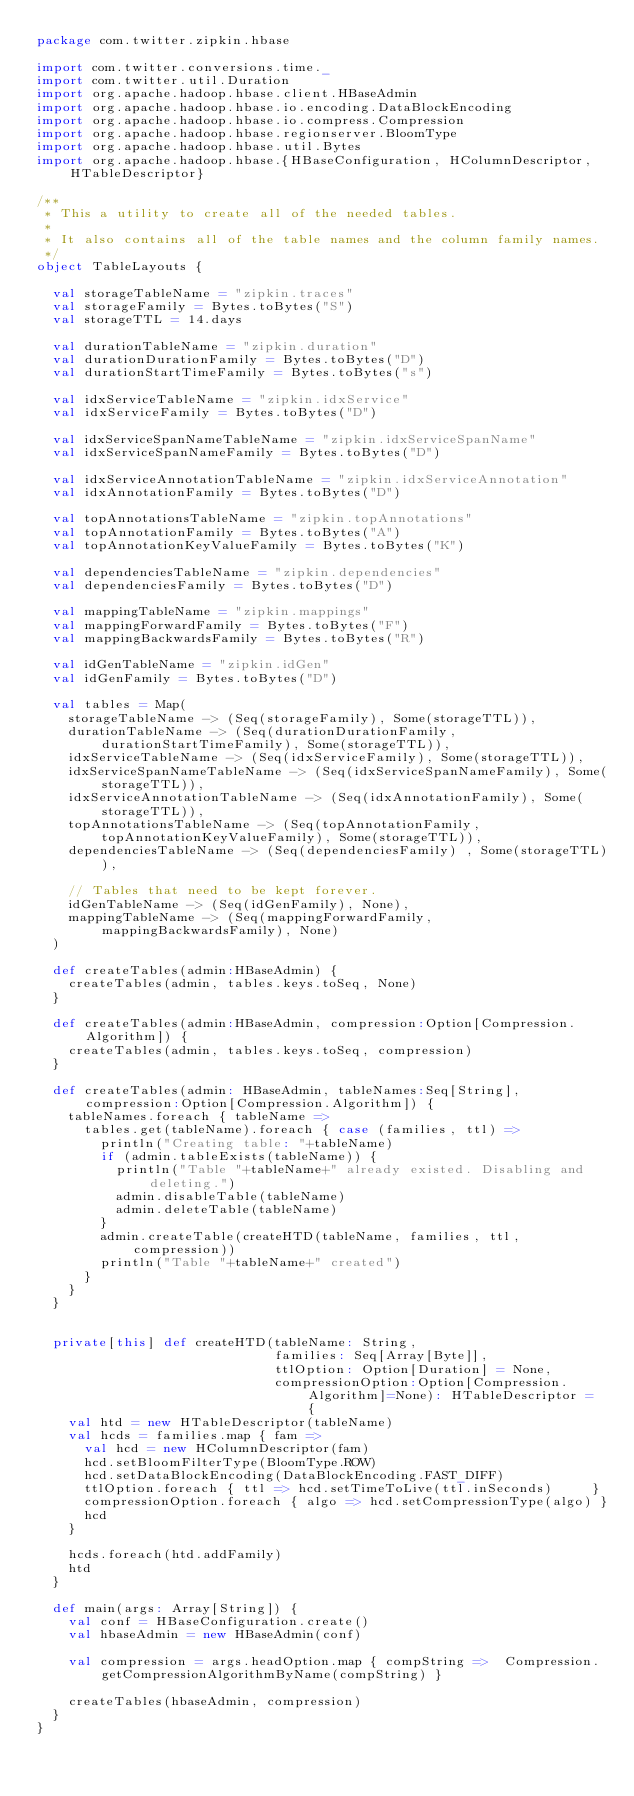<code> <loc_0><loc_0><loc_500><loc_500><_Scala_>package com.twitter.zipkin.hbase

import com.twitter.conversions.time._
import com.twitter.util.Duration
import org.apache.hadoop.hbase.client.HBaseAdmin
import org.apache.hadoop.hbase.io.encoding.DataBlockEncoding
import org.apache.hadoop.hbase.io.compress.Compression
import org.apache.hadoop.hbase.regionserver.BloomType
import org.apache.hadoop.hbase.util.Bytes
import org.apache.hadoop.hbase.{HBaseConfiguration, HColumnDescriptor, HTableDescriptor}

/**
 * This a utility to create all of the needed tables.
 *
 * It also contains all of the table names and the column family names.
 */
object TableLayouts {

  val storageTableName = "zipkin.traces"
  val storageFamily = Bytes.toBytes("S")
  val storageTTL = 14.days

  val durationTableName = "zipkin.duration"
  val durationDurationFamily = Bytes.toBytes("D")
  val durationStartTimeFamily = Bytes.toBytes("s")

  val idxServiceTableName = "zipkin.idxService"
  val idxServiceFamily = Bytes.toBytes("D")

  val idxServiceSpanNameTableName = "zipkin.idxServiceSpanName"
  val idxServiceSpanNameFamily = Bytes.toBytes("D")

  val idxServiceAnnotationTableName = "zipkin.idxServiceAnnotation"
  val idxAnnotationFamily = Bytes.toBytes("D")

  val topAnnotationsTableName = "zipkin.topAnnotations"
  val topAnnotationFamily = Bytes.toBytes("A")
  val topAnnotationKeyValueFamily = Bytes.toBytes("K")

  val dependenciesTableName = "zipkin.dependencies"
  val dependenciesFamily = Bytes.toBytes("D")

  val mappingTableName = "zipkin.mappings"
  val mappingForwardFamily = Bytes.toBytes("F")
  val mappingBackwardsFamily = Bytes.toBytes("R")

  val idGenTableName = "zipkin.idGen"
  val idGenFamily = Bytes.toBytes("D")

  val tables = Map(
    storageTableName -> (Seq(storageFamily), Some(storageTTL)),
    durationTableName -> (Seq(durationDurationFamily, durationStartTimeFamily), Some(storageTTL)),
    idxServiceTableName -> (Seq(idxServiceFamily), Some(storageTTL)),
    idxServiceSpanNameTableName -> (Seq(idxServiceSpanNameFamily), Some(storageTTL)),
    idxServiceAnnotationTableName -> (Seq(idxAnnotationFamily), Some(storageTTL)),
    topAnnotationsTableName -> (Seq(topAnnotationFamily, topAnnotationKeyValueFamily), Some(storageTTL)),
    dependenciesTableName -> (Seq(dependenciesFamily) , Some(storageTTL)),

    // Tables that need to be kept forever.
    idGenTableName -> (Seq(idGenFamily), None),
    mappingTableName -> (Seq(mappingForwardFamily, mappingBackwardsFamily), None)
  )

  def createTables(admin:HBaseAdmin) {
    createTables(admin, tables.keys.toSeq, None)
  }

  def createTables(admin:HBaseAdmin, compression:Option[Compression.Algorithm]) {
    createTables(admin, tables.keys.toSeq, compression)
  }

  def createTables(admin: HBaseAdmin, tableNames:Seq[String], compression:Option[Compression.Algorithm]) {
    tableNames.foreach { tableName =>
      tables.get(tableName).foreach { case (families, ttl) =>
        println("Creating table: "+tableName)
        if (admin.tableExists(tableName)) {
          println("Table "+tableName+" already existed. Disabling and deleting.")
          admin.disableTable(tableName)
          admin.deleteTable(tableName)
        }
        admin.createTable(createHTD(tableName, families, ttl, compression))
        println("Table "+tableName+" created")
      }
    }
  }


  private[this] def createHTD(tableName: String,
                              families: Seq[Array[Byte]],
                              ttlOption: Option[Duration] = None,
                              compressionOption:Option[Compression.Algorithm]=None): HTableDescriptor = {
    val htd = new HTableDescriptor(tableName)
    val hcds = families.map { fam =>
      val hcd = new HColumnDescriptor(fam)
      hcd.setBloomFilterType(BloomType.ROW)
      hcd.setDataBlockEncoding(DataBlockEncoding.FAST_DIFF)
      ttlOption.foreach { ttl => hcd.setTimeToLive(ttl.inSeconds)     }
      compressionOption.foreach { algo => hcd.setCompressionType(algo) }
      hcd
    }

    hcds.foreach(htd.addFamily)
    htd
  }

  def main(args: Array[String]) {
    val conf = HBaseConfiguration.create()
    val hbaseAdmin = new HBaseAdmin(conf)

    val compression = args.headOption.map { compString =>  Compression.getCompressionAlgorithmByName(compString) }

    createTables(hbaseAdmin, compression)
  }
}
</code> 